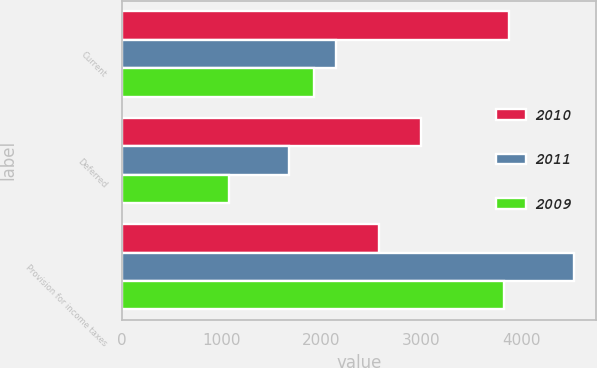Convert chart to OTSL. <chart><loc_0><loc_0><loc_500><loc_500><stacked_bar_chart><ecel><fcel>Current<fcel>Deferred<fcel>Provision for income taxes<nl><fcel>2010<fcel>3884<fcel>2998<fcel>2574<nl><fcel>2011<fcel>2150<fcel>1676<fcel>4527<nl><fcel>2009<fcel>1922<fcel>1077<fcel>3831<nl></chart> 